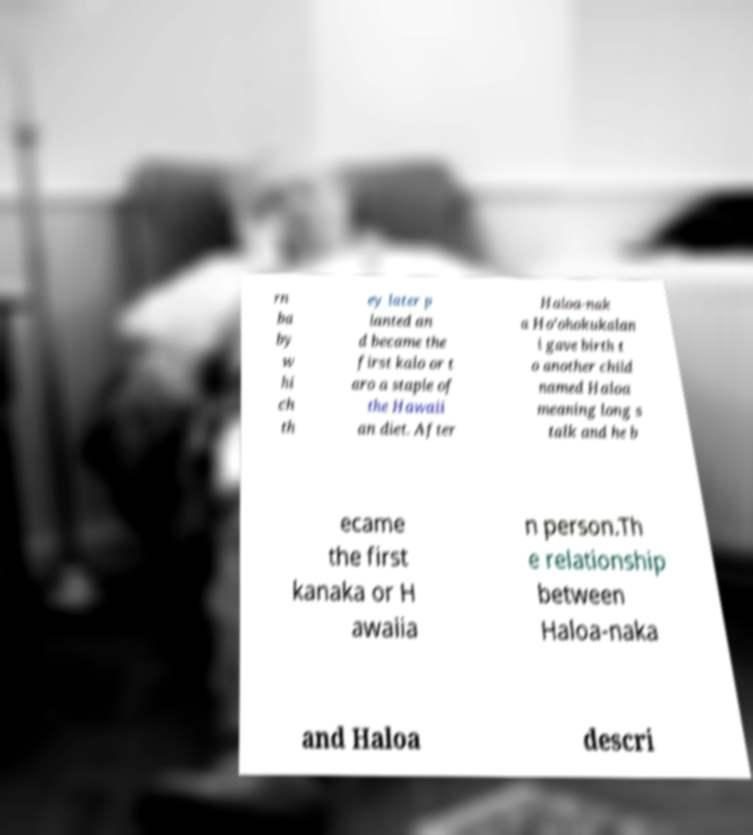Could you assist in decoding the text presented in this image and type it out clearly? rn ba by w hi ch th ey later p lanted an d became the first kalo or t aro a staple of the Hawaii an diet. After Haloa-nak a Ho’ohokukalan i gave birth t o another child named Haloa meaning long s talk and he b ecame the first kanaka or H awaiia n person.Th e relationship between Haloa-naka and Haloa descri 